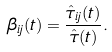<formula> <loc_0><loc_0><loc_500><loc_500>\beta _ { i j } ( t ) = \frac { \hat { \tau } _ { i j } ( t ) } { \hat { \tau } ( t ) } .</formula> 